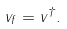<formula> <loc_0><loc_0><loc_500><loc_500>v _ { f } = v ^ { \dagger } .</formula> 